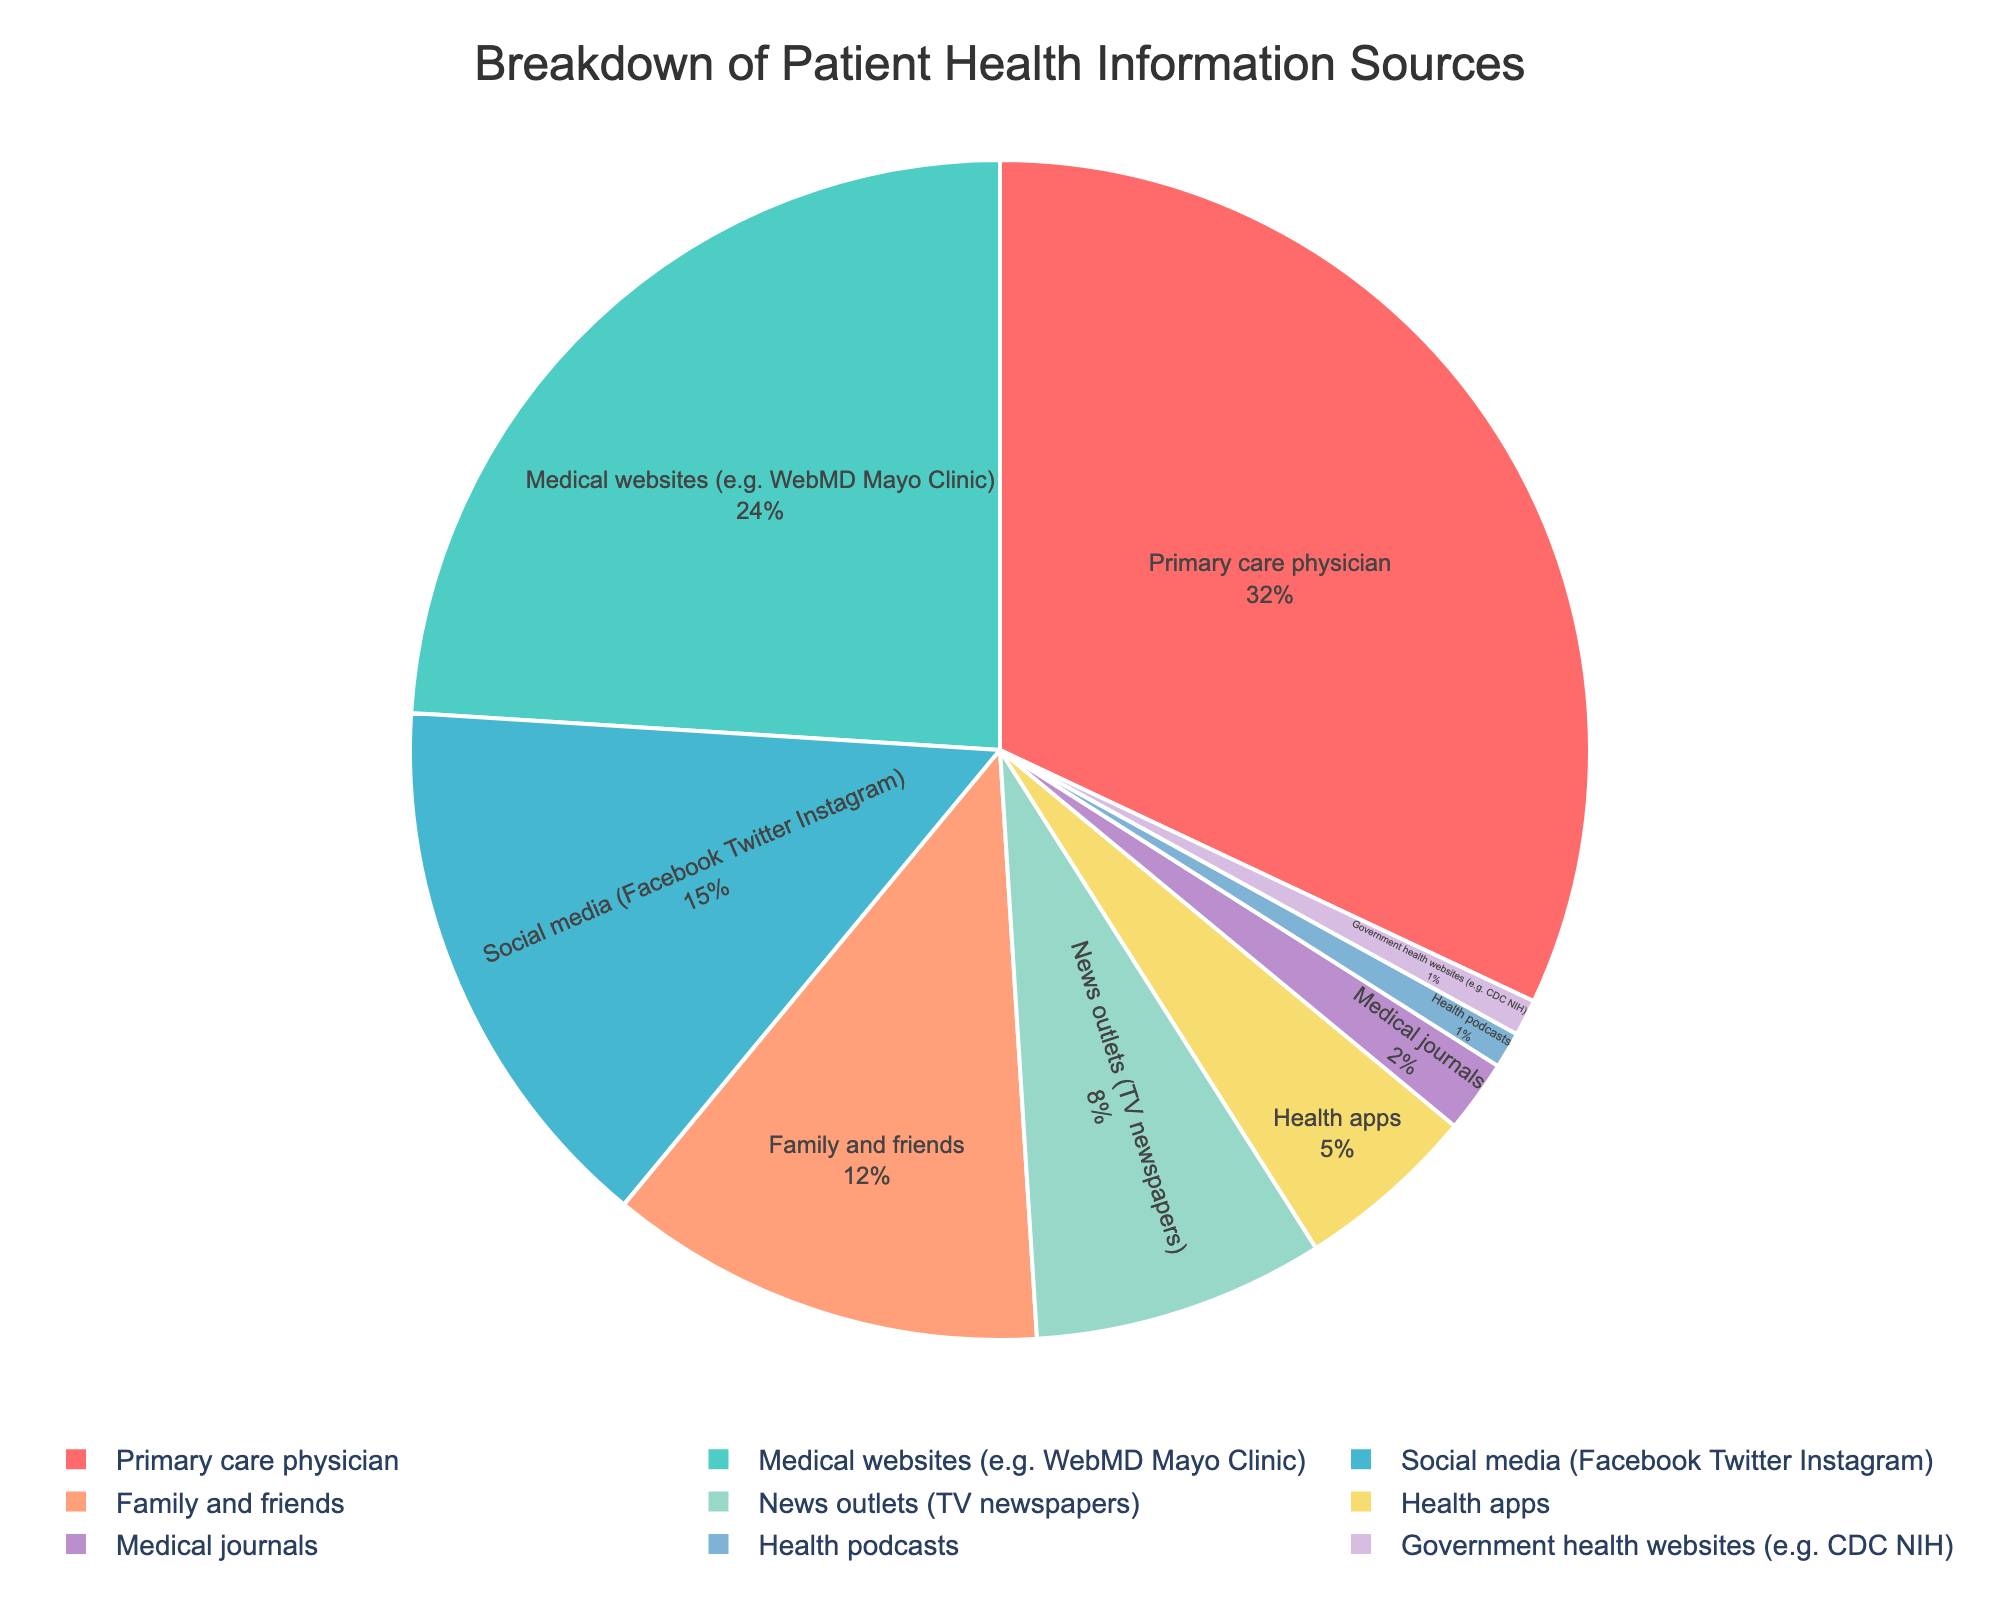Which source has the highest percentage? The pie chart shows different sources with corresponding percentages. The largest segment, representing 32%, belongs to Primary care physician.
Answer: Primary care physician How much larger is the percentage of information sourced from medical websites compared to social media? To find this, subtract the percentage of social media from the percentage of medical websites. The medical websites have 24%, and social media have 15%, so 24 - 15 = 9%.
Answer: 9% What is the combined percentage of sources from social media and family and friends? Add the percentages of social media and family and friends. Social media is 15%, and family and friends is 12%, so 15 + 12 = 27%.
Answer: 27% Is the percentage of information from news outlets larger than from government health websites? Compare the percentages of news outlets (8%) and government health websites (1%). Since 8% is greater than 1%, news outlets contribute more.
Answer: Yes Which source contributes the smallest percentage of health information? Look for the smallest segment in the pie chart, which has the value of 1%. This corresponds to health podcasts and government health websites.
Answer: Health podcasts / Government health websites What is the total percentage of health information sourced from either medical journals or health podcasts? Add the percentages of medical journals (2%) and health podcasts (1%), so 2 + 1 = 3%.
Answer: 3% How many times larger is the percentage of information from the primary care physician compared to health apps? Divide the percentage of the primary care physician (32%) by the percentage of health apps (5%). So, 32 / 5 ≈ 6.4 times.
Answer: 6.4 times Which sources have a percentage difference of more than 10%? Check the pairs to identify differences greater than 10%. For example, Primary care physician (32%) and news outlets (8%) have a difference of 24%, which is more than 10%. Similarly, multiple other pairs can be checked.
Answer: Primary care physician vs Medical websites, and others by manual checking What is the percentage difference between medical websites and health apps? Subtract the percentage of health apps (5%) from the percentage of medical websites (24%). So, 24 - 5 = 19%.
Answer: 19% Identify the segments in the pie chart which are colored with shades of blue. Visually inspect the pie chart. Medical websites (24%) and medical journals (2%) are colored using shades of blue.
Answer: Medical websites, Medical journals 